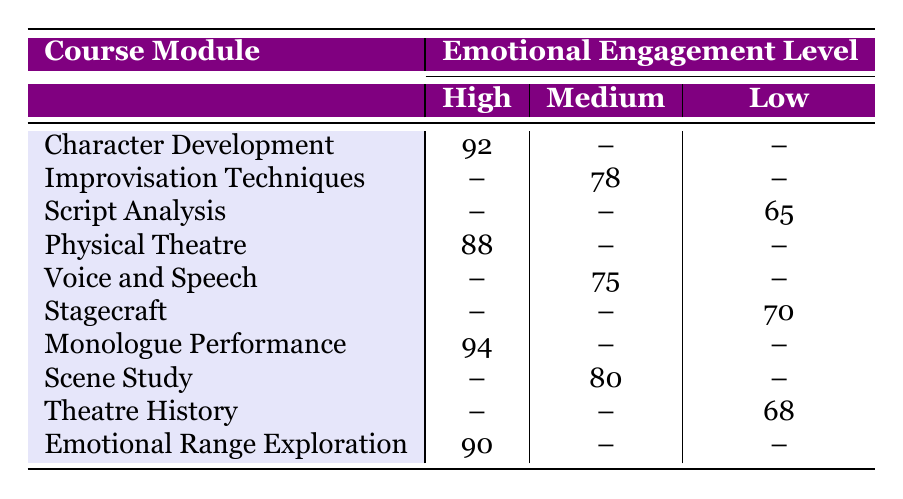What is the performance score for Emily Johnson in Character Development? The table shows that Emily Johnson has a performance score of 92 in the Character Development module under high emotional engagement.
Answer: 92 Which course module had the highest performance score? By comparing the performance scores across all course modules, Monologue Performance has the highest score of 94.
Answer: Monologue Performance What is the average performance score for students with medium emotional engagement? The scores for medium emotional engagement are 78 (Improvisation Techniques), 75 (Voice and Speech), and 80 (Scene Study). Adding these gives 233, and dividing by 3 (the number of scores) gives an average of 77.67.
Answer: 77.67 Do any students with low emotional engagement score above 70? The table shows that only David Martinez scored 70 in Stagecraft and Olivia Hernandez scored 68 in Theatre History, meaning no low emotional engagement students scored above 70.
Answer: No What is the difference between the highest score in high emotional engagement and the lowest score in low emotional engagement? The highest score in high emotional engagement is 94 (Monologue Performance), and the lowest score in low emotional engagement is 65 (Script Analysis). The difference is calculated as 94 - 65 = 29.
Answer: 29 How many students scored above 80 overall? The students scoring above 80 are Emily Johnson (92), Sophia Garcia (94), William Lee (90), and Daniel Wilson (88), totaling 4 students.
Answer: 4 Is there a course module where all students scored below 70? Referring to the table, Theatre History (68) and Script Analysis (65) have scores below 70, confirming there are course modules where all students scored below 70.
Answer: Yes Which emotional engagement level has the most students represented in the table? The table shows there are 4 students at high emotional engagement, 3 at medium, and 3 at low, indicating that high emotional engagement has the most students.
Answer: High What is the performance score for the course module Voice and Speech? The table indicates that Sarah Davis scored 75 in the Voice and Speech module under medium emotional engagement.
Answer: 75 